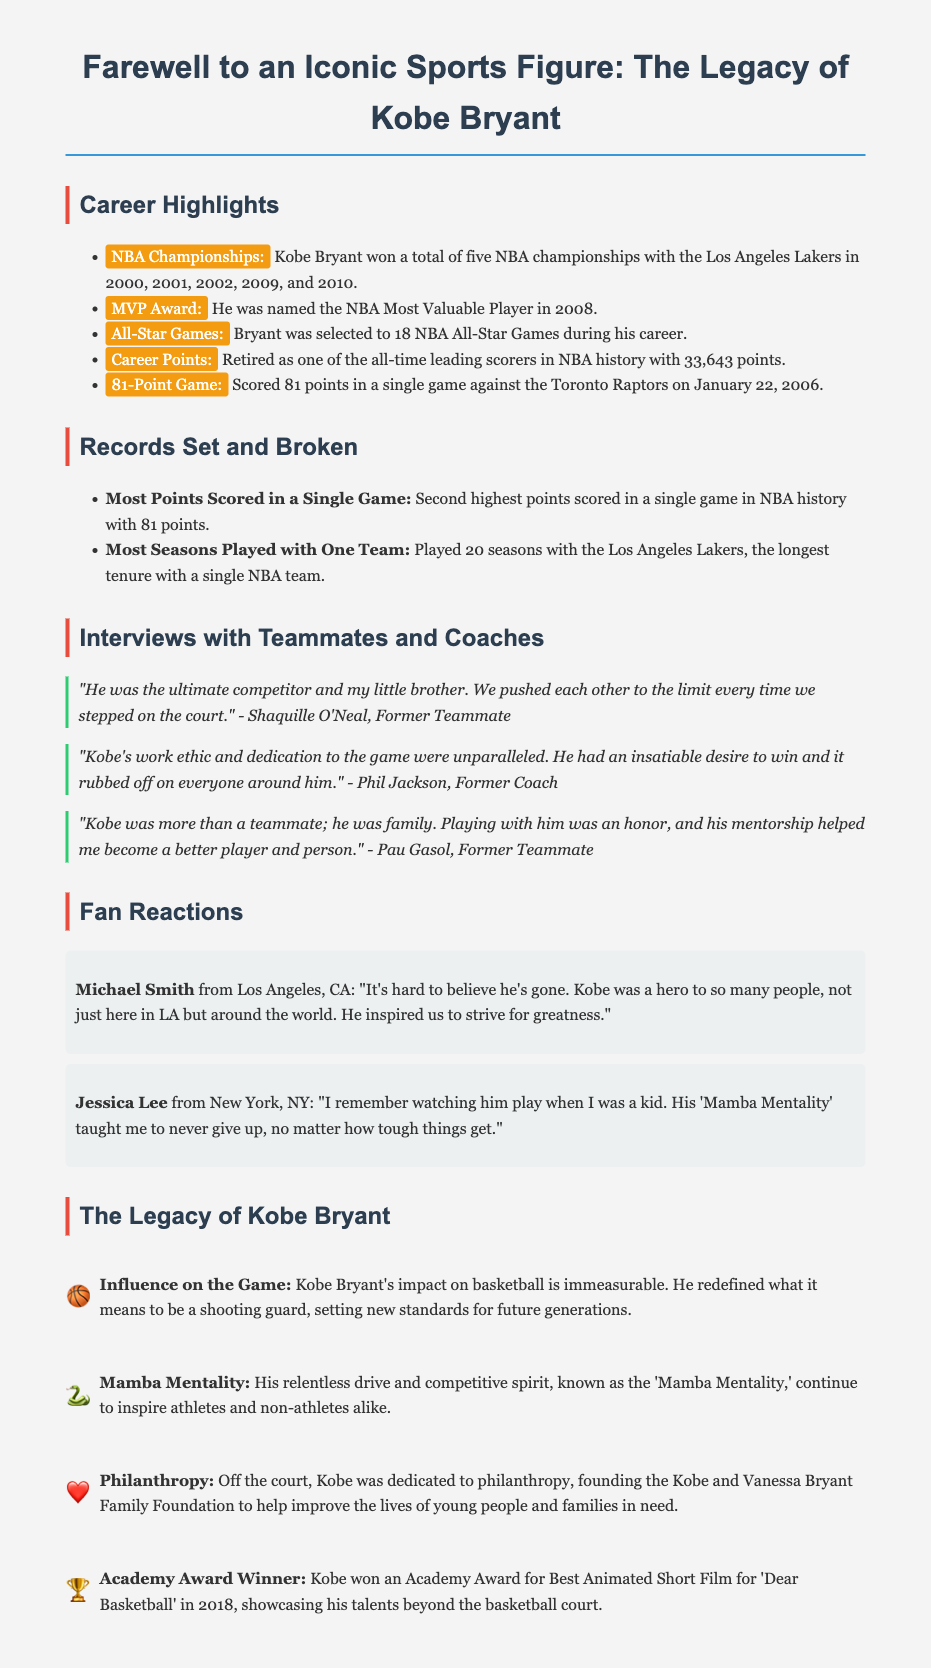What year was Kobe Bryant named MVP? The document states that Kobe Bryant was named the NBA Most Valuable Player in 2008.
Answer: 2008 How many championships did Kobe Bryant win? The document lists that Kobe Bryant won a total of five NBA championships with the Los Angeles Lakers.
Answer: Five Who was Kobe's former teammate that described him as "the ultimate competitor"? The quote in the document attributes this description to Shaquille O'Neal.
Answer: Shaquille O'Neal What is the significance of "81 points" in Kobe's career? The document highlights that he scored 81 points in a single game against the Toronto Raptors on January 22, 2006, making it an important milestone.
Answer: 81 points What phrase is associated with Kobe's competitive spirit? The document refers to the term 'Mamba Mentality' to describe Kobe's relentless drive and competitive spirit.
Answer: Mamba Mentality How many All-Star Games was Kobe selected for during his career? The document mentions that he was selected to 18 NBA All-Star Games.
Answer: 18 What did Phil Jackson say about Kobe's work ethic? Phil Jackson stated that Kobe's work ethic and dedication were unparalleled, as mentioned in the quotes section.
Answer: Unparalleled What philanthropic foundation did Kobe establish? The document states that he founded the Kobe and Vanessa Bryant Family Foundation.
Answer: Kobe and Vanessa Bryant Family Foundation What notable achievement did Kobe receive in 2018? The Obituary highlights that Kobe won an Academy Award for Best Animated Short Film for 'Dear Basketball' in 2018.
Answer: Academy Award 